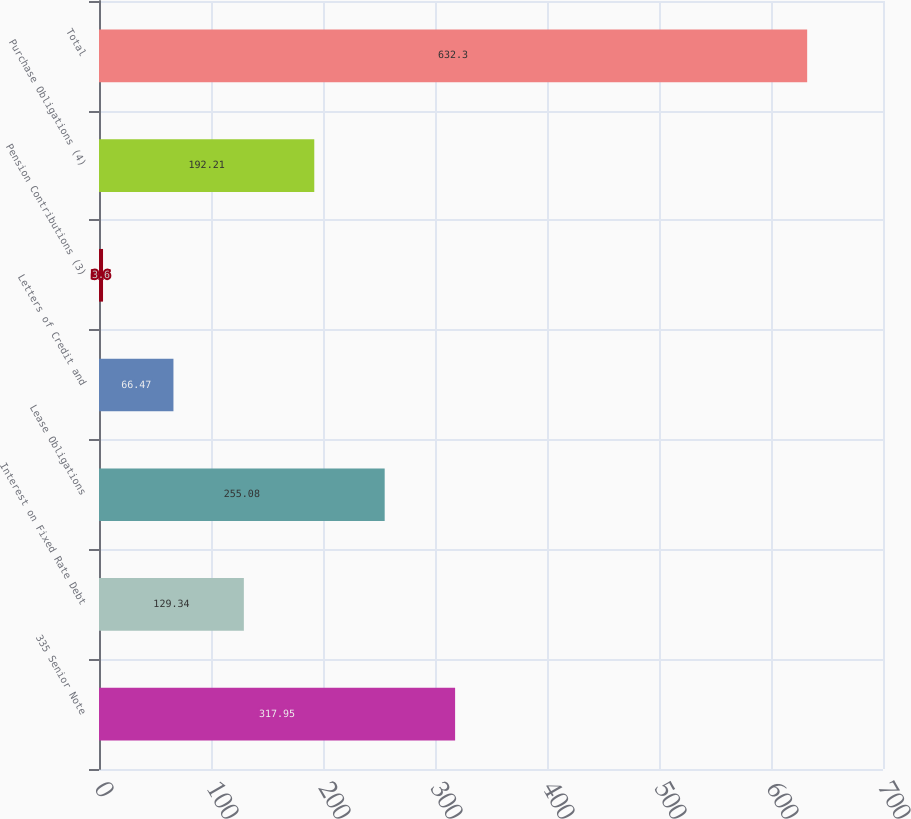Convert chart. <chart><loc_0><loc_0><loc_500><loc_500><bar_chart><fcel>335 Senior Note<fcel>Interest on Fixed Rate Debt<fcel>Lease Obligations<fcel>Letters of Credit and<fcel>Pension Contributions (3)<fcel>Purchase Obligations (4)<fcel>Total<nl><fcel>317.95<fcel>129.34<fcel>255.08<fcel>66.47<fcel>3.6<fcel>192.21<fcel>632.3<nl></chart> 